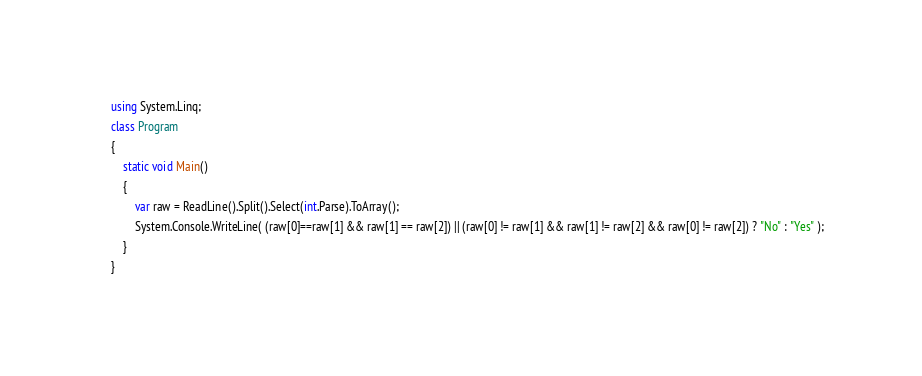Convert code to text. <code><loc_0><loc_0><loc_500><loc_500><_C#_>using System.Linq;
class Program
{
    static void Main()
    {
        var raw = ReadLine().Split().Select(int.Parse).ToArray();
        System.Console.WriteLine( (raw[0]==raw[1] && raw[1] == raw[2]) || (raw[0] != raw[1] && raw[1] != raw[2] && raw[0] != raw[2]) ? "No" : "Yes" );
    }
}
</code> 